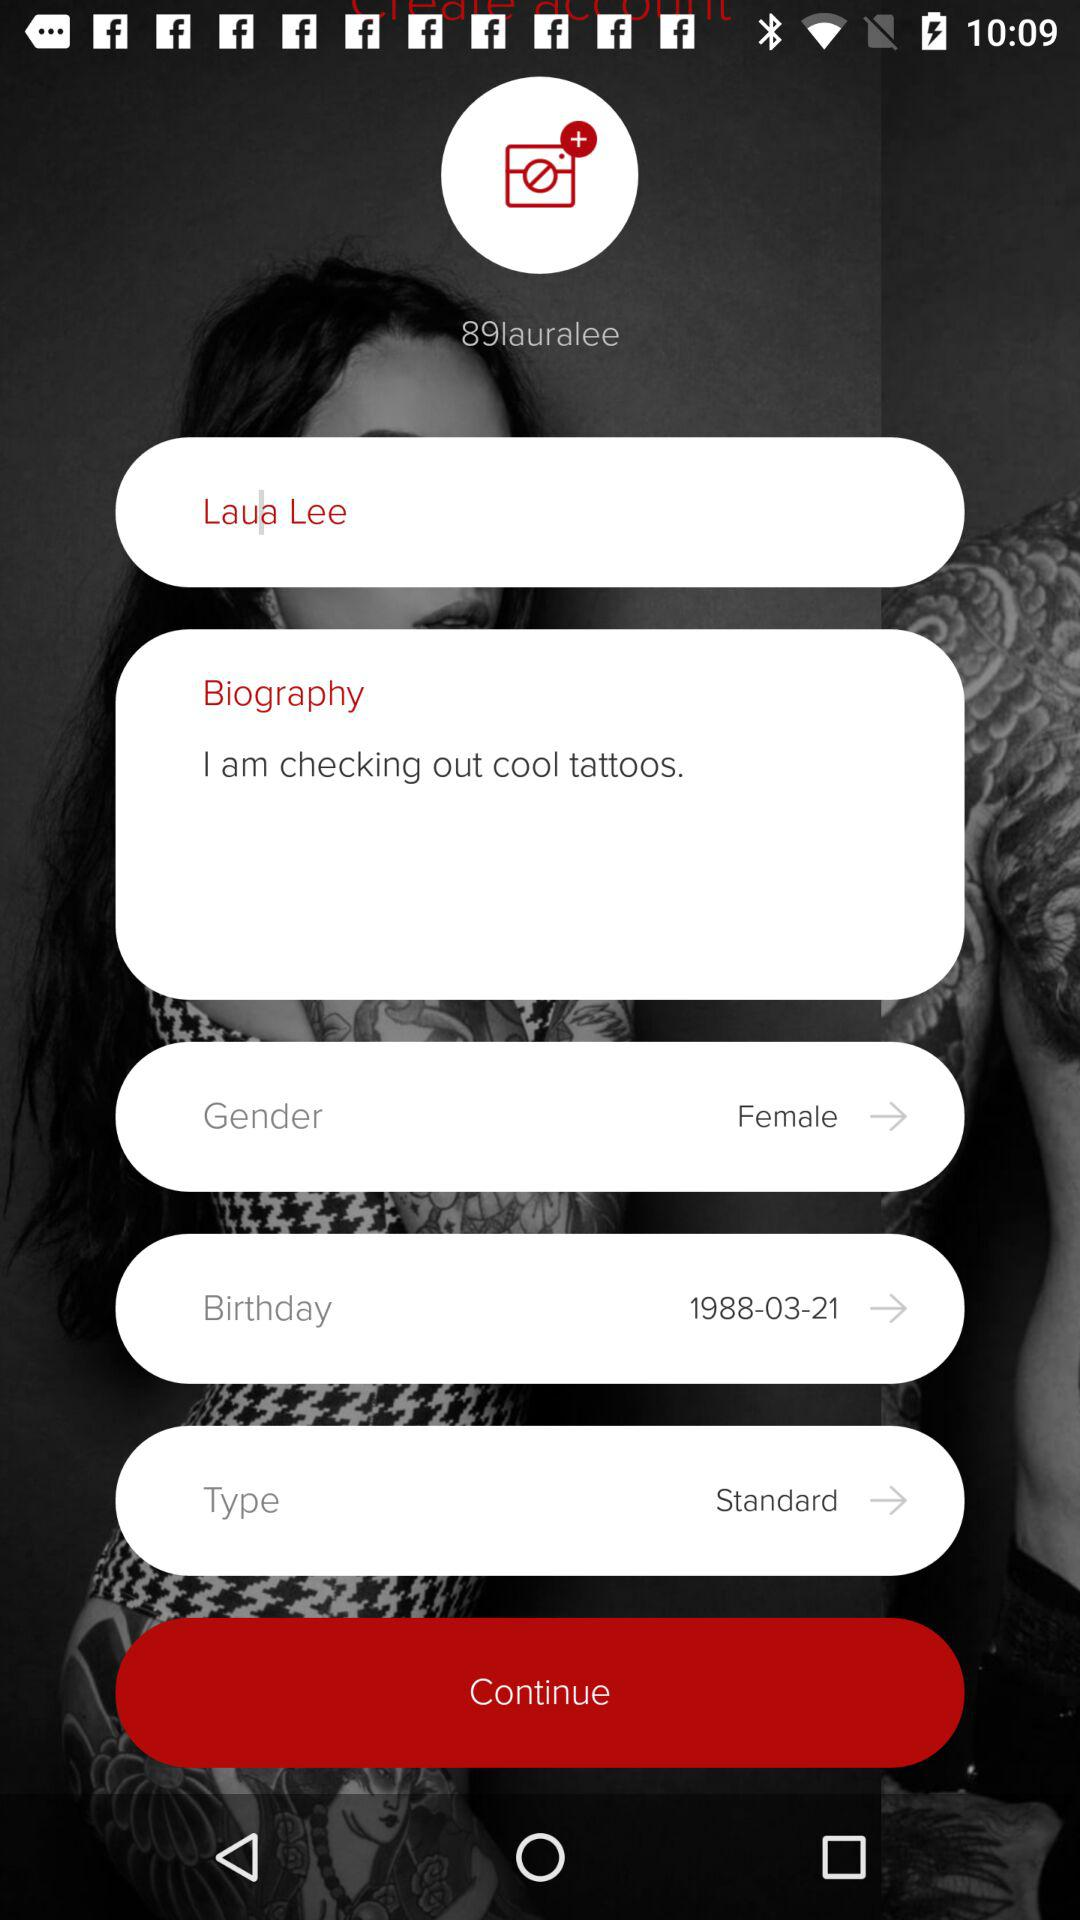What is the "Type"? The "Type" is "Standard". 